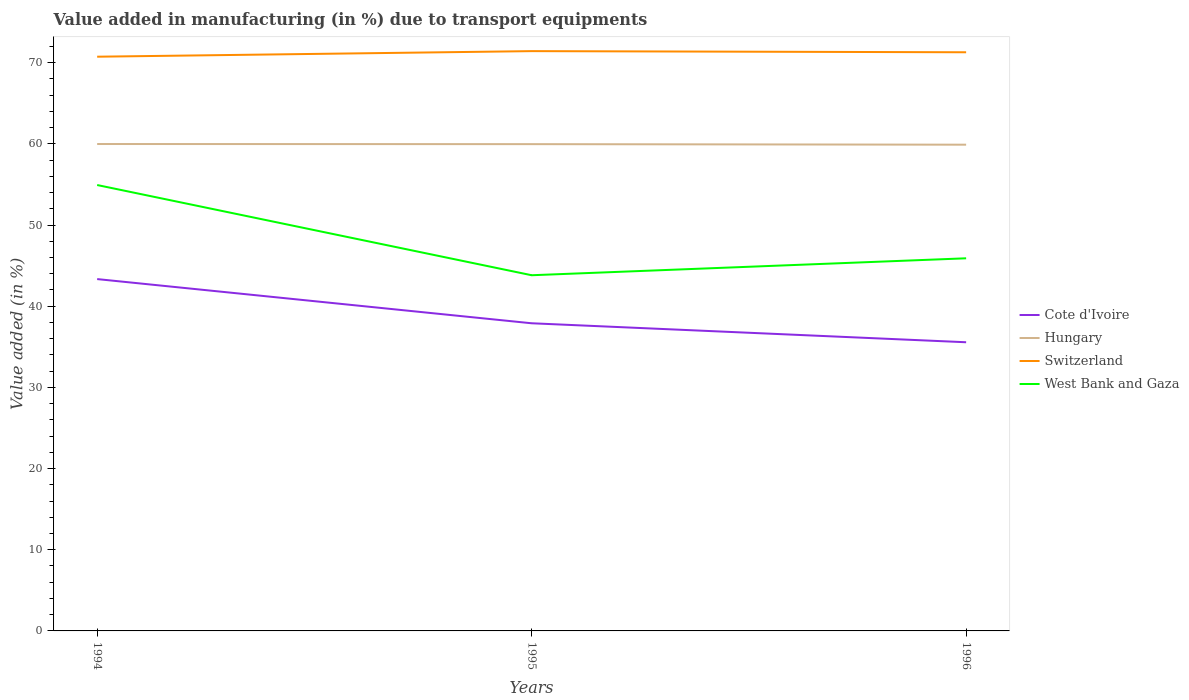Is the number of lines equal to the number of legend labels?
Your response must be concise. Yes. Across all years, what is the maximum percentage of value added in manufacturing due to transport equipments in Cote d'Ivoire?
Your answer should be compact. 35.56. What is the total percentage of value added in manufacturing due to transport equipments in Hungary in the graph?
Provide a short and direct response. 0.02. What is the difference between the highest and the second highest percentage of value added in manufacturing due to transport equipments in Hungary?
Offer a very short reply. 0.08. What is the difference between two consecutive major ticks on the Y-axis?
Make the answer very short. 10. Are the values on the major ticks of Y-axis written in scientific E-notation?
Give a very brief answer. No. Where does the legend appear in the graph?
Make the answer very short. Center right. What is the title of the graph?
Give a very brief answer. Value added in manufacturing (in %) due to transport equipments. What is the label or title of the Y-axis?
Provide a short and direct response. Value added (in %). What is the Value added (in %) in Cote d'Ivoire in 1994?
Provide a succinct answer. 43.34. What is the Value added (in %) in Hungary in 1994?
Provide a short and direct response. 59.98. What is the Value added (in %) of Switzerland in 1994?
Your answer should be compact. 70.74. What is the Value added (in %) of West Bank and Gaza in 1994?
Ensure brevity in your answer.  54.93. What is the Value added (in %) in Cote d'Ivoire in 1995?
Your answer should be very brief. 37.9. What is the Value added (in %) of Hungary in 1995?
Keep it short and to the point. 59.97. What is the Value added (in %) in Switzerland in 1995?
Keep it short and to the point. 71.42. What is the Value added (in %) in West Bank and Gaza in 1995?
Provide a succinct answer. 43.82. What is the Value added (in %) in Cote d'Ivoire in 1996?
Give a very brief answer. 35.56. What is the Value added (in %) in Hungary in 1996?
Offer a very short reply. 59.9. What is the Value added (in %) in Switzerland in 1996?
Offer a very short reply. 71.28. What is the Value added (in %) of West Bank and Gaza in 1996?
Provide a succinct answer. 45.9. Across all years, what is the maximum Value added (in %) in Cote d'Ivoire?
Make the answer very short. 43.34. Across all years, what is the maximum Value added (in %) of Hungary?
Offer a terse response. 59.98. Across all years, what is the maximum Value added (in %) in Switzerland?
Your response must be concise. 71.42. Across all years, what is the maximum Value added (in %) in West Bank and Gaza?
Make the answer very short. 54.93. Across all years, what is the minimum Value added (in %) in Cote d'Ivoire?
Offer a very short reply. 35.56. Across all years, what is the minimum Value added (in %) in Hungary?
Make the answer very short. 59.9. Across all years, what is the minimum Value added (in %) in Switzerland?
Ensure brevity in your answer.  70.74. Across all years, what is the minimum Value added (in %) of West Bank and Gaza?
Keep it short and to the point. 43.82. What is the total Value added (in %) in Cote d'Ivoire in the graph?
Keep it short and to the point. 116.8. What is the total Value added (in %) in Hungary in the graph?
Your answer should be compact. 179.84. What is the total Value added (in %) of Switzerland in the graph?
Provide a short and direct response. 213.44. What is the total Value added (in %) of West Bank and Gaza in the graph?
Your response must be concise. 144.65. What is the difference between the Value added (in %) in Cote d'Ivoire in 1994 and that in 1995?
Your answer should be very brief. 5.44. What is the difference between the Value added (in %) of Hungary in 1994 and that in 1995?
Make the answer very short. 0.01. What is the difference between the Value added (in %) of Switzerland in 1994 and that in 1995?
Offer a very short reply. -0.69. What is the difference between the Value added (in %) of West Bank and Gaza in 1994 and that in 1995?
Offer a very short reply. 11.11. What is the difference between the Value added (in %) of Cote d'Ivoire in 1994 and that in 1996?
Ensure brevity in your answer.  7.78. What is the difference between the Value added (in %) of Hungary in 1994 and that in 1996?
Your answer should be compact. 0.08. What is the difference between the Value added (in %) of Switzerland in 1994 and that in 1996?
Your response must be concise. -0.55. What is the difference between the Value added (in %) in West Bank and Gaza in 1994 and that in 1996?
Your answer should be very brief. 9.03. What is the difference between the Value added (in %) of Cote d'Ivoire in 1995 and that in 1996?
Give a very brief answer. 2.34. What is the difference between the Value added (in %) in Hungary in 1995 and that in 1996?
Offer a very short reply. 0.07. What is the difference between the Value added (in %) of Switzerland in 1995 and that in 1996?
Offer a very short reply. 0.14. What is the difference between the Value added (in %) of West Bank and Gaza in 1995 and that in 1996?
Your response must be concise. -2.09. What is the difference between the Value added (in %) of Cote d'Ivoire in 1994 and the Value added (in %) of Hungary in 1995?
Provide a succinct answer. -16.62. What is the difference between the Value added (in %) of Cote d'Ivoire in 1994 and the Value added (in %) of Switzerland in 1995?
Offer a very short reply. -28.08. What is the difference between the Value added (in %) in Cote d'Ivoire in 1994 and the Value added (in %) in West Bank and Gaza in 1995?
Keep it short and to the point. -0.48. What is the difference between the Value added (in %) in Hungary in 1994 and the Value added (in %) in Switzerland in 1995?
Offer a very short reply. -11.44. What is the difference between the Value added (in %) in Hungary in 1994 and the Value added (in %) in West Bank and Gaza in 1995?
Your answer should be very brief. 16.16. What is the difference between the Value added (in %) of Switzerland in 1994 and the Value added (in %) of West Bank and Gaza in 1995?
Make the answer very short. 26.92. What is the difference between the Value added (in %) in Cote d'Ivoire in 1994 and the Value added (in %) in Hungary in 1996?
Your answer should be compact. -16.56. What is the difference between the Value added (in %) of Cote d'Ivoire in 1994 and the Value added (in %) of Switzerland in 1996?
Provide a short and direct response. -27.94. What is the difference between the Value added (in %) of Cote d'Ivoire in 1994 and the Value added (in %) of West Bank and Gaza in 1996?
Provide a short and direct response. -2.56. What is the difference between the Value added (in %) of Hungary in 1994 and the Value added (in %) of Switzerland in 1996?
Ensure brevity in your answer.  -11.3. What is the difference between the Value added (in %) in Hungary in 1994 and the Value added (in %) in West Bank and Gaza in 1996?
Ensure brevity in your answer.  14.08. What is the difference between the Value added (in %) in Switzerland in 1994 and the Value added (in %) in West Bank and Gaza in 1996?
Give a very brief answer. 24.83. What is the difference between the Value added (in %) in Cote d'Ivoire in 1995 and the Value added (in %) in Hungary in 1996?
Give a very brief answer. -22. What is the difference between the Value added (in %) in Cote d'Ivoire in 1995 and the Value added (in %) in Switzerland in 1996?
Give a very brief answer. -33.39. What is the difference between the Value added (in %) of Cote d'Ivoire in 1995 and the Value added (in %) of West Bank and Gaza in 1996?
Keep it short and to the point. -8. What is the difference between the Value added (in %) in Hungary in 1995 and the Value added (in %) in Switzerland in 1996?
Provide a short and direct response. -11.32. What is the difference between the Value added (in %) of Hungary in 1995 and the Value added (in %) of West Bank and Gaza in 1996?
Give a very brief answer. 14.06. What is the difference between the Value added (in %) of Switzerland in 1995 and the Value added (in %) of West Bank and Gaza in 1996?
Offer a very short reply. 25.52. What is the average Value added (in %) of Cote d'Ivoire per year?
Your answer should be compact. 38.93. What is the average Value added (in %) in Hungary per year?
Provide a short and direct response. 59.95. What is the average Value added (in %) in Switzerland per year?
Provide a succinct answer. 71.15. What is the average Value added (in %) in West Bank and Gaza per year?
Give a very brief answer. 48.22. In the year 1994, what is the difference between the Value added (in %) in Cote d'Ivoire and Value added (in %) in Hungary?
Your response must be concise. -16.64. In the year 1994, what is the difference between the Value added (in %) of Cote d'Ivoire and Value added (in %) of Switzerland?
Offer a terse response. -27.4. In the year 1994, what is the difference between the Value added (in %) of Cote d'Ivoire and Value added (in %) of West Bank and Gaza?
Your answer should be very brief. -11.59. In the year 1994, what is the difference between the Value added (in %) in Hungary and Value added (in %) in Switzerland?
Your answer should be compact. -10.76. In the year 1994, what is the difference between the Value added (in %) in Hungary and Value added (in %) in West Bank and Gaza?
Your answer should be very brief. 5.05. In the year 1994, what is the difference between the Value added (in %) in Switzerland and Value added (in %) in West Bank and Gaza?
Make the answer very short. 15.81. In the year 1995, what is the difference between the Value added (in %) in Cote d'Ivoire and Value added (in %) in Hungary?
Your answer should be very brief. -22.07. In the year 1995, what is the difference between the Value added (in %) of Cote d'Ivoire and Value added (in %) of Switzerland?
Provide a short and direct response. -33.52. In the year 1995, what is the difference between the Value added (in %) of Cote d'Ivoire and Value added (in %) of West Bank and Gaza?
Offer a terse response. -5.92. In the year 1995, what is the difference between the Value added (in %) in Hungary and Value added (in %) in Switzerland?
Your response must be concise. -11.46. In the year 1995, what is the difference between the Value added (in %) in Hungary and Value added (in %) in West Bank and Gaza?
Offer a terse response. 16.15. In the year 1995, what is the difference between the Value added (in %) in Switzerland and Value added (in %) in West Bank and Gaza?
Give a very brief answer. 27.61. In the year 1996, what is the difference between the Value added (in %) of Cote d'Ivoire and Value added (in %) of Hungary?
Provide a succinct answer. -24.34. In the year 1996, what is the difference between the Value added (in %) of Cote d'Ivoire and Value added (in %) of Switzerland?
Your answer should be very brief. -35.72. In the year 1996, what is the difference between the Value added (in %) in Cote d'Ivoire and Value added (in %) in West Bank and Gaza?
Your response must be concise. -10.34. In the year 1996, what is the difference between the Value added (in %) of Hungary and Value added (in %) of Switzerland?
Offer a terse response. -11.39. In the year 1996, what is the difference between the Value added (in %) of Hungary and Value added (in %) of West Bank and Gaza?
Your answer should be very brief. 13.99. In the year 1996, what is the difference between the Value added (in %) in Switzerland and Value added (in %) in West Bank and Gaza?
Give a very brief answer. 25.38. What is the ratio of the Value added (in %) of Cote d'Ivoire in 1994 to that in 1995?
Keep it short and to the point. 1.14. What is the ratio of the Value added (in %) in Switzerland in 1994 to that in 1995?
Provide a succinct answer. 0.99. What is the ratio of the Value added (in %) in West Bank and Gaza in 1994 to that in 1995?
Provide a succinct answer. 1.25. What is the ratio of the Value added (in %) of Cote d'Ivoire in 1994 to that in 1996?
Your answer should be very brief. 1.22. What is the ratio of the Value added (in %) of Switzerland in 1994 to that in 1996?
Ensure brevity in your answer.  0.99. What is the ratio of the Value added (in %) in West Bank and Gaza in 1994 to that in 1996?
Offer a very short reply. 1.2. What is the ratio of the Value added (in %) in Cote d'Ivoire in 1995 to that in 1996?
Provide a succinct answer. 1.07. What is the ratio of the Value added (in %) in West Bank and Gaza in 1995 to that in 1996?
Make the answer very short. 0.95. What is the difference between the highest and the second highest Value added (in %) in Cote d'Ivoire?
Make the answer very short. 5.44. What is the difference between the highest and the second highest Value added (in %) of Hungary?
Your response must be concise. 0.01. What is the difference between the highest and the second highest Value added (in %) in Switzerland?
Give a very brief answer. 0.14. What is the difference between the highest and the second highest Value added (in %) in West Bank and Gaza?
Your answer should be compact. 9.03. What is the difference between the highest and the lowest Value added (in %) in Cote d'Ivoire?
Ensure brevity in your answer.  7.78. What is the difference between the highest and the lowest Value added (in %) of Hungary?
Give a very brief answer. 0.08. What is the difference between the highest and the lowest Value added (in %) of Switzerland?
Offer a very short reply. 0.69. What is the difference between the highest and the lowest Value added (in %) in West Bank and Gaza?
Your response must be concise. 11.11. 